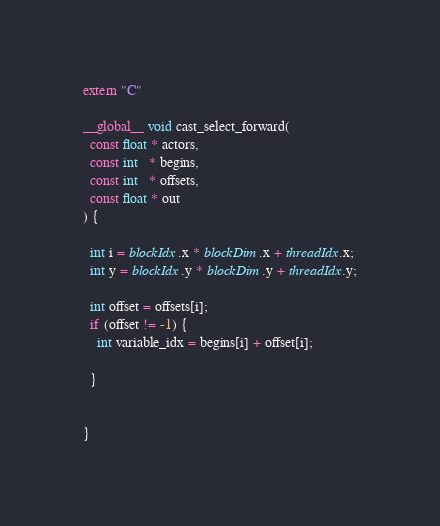<code> <loc_0><loc_0><loc_500><loc_500><_Cuda_>extern "C"

__global__ void cast_select_forward(
  const float * actors,
  const int   * begins,
  const int   * offsets,
  const float * out
) {

  int i = blockIdx.x * blockDim.x + threadIdx.x;
  int y = blockIdx.y * blockDim.y + threadIdx.y;

  int offset = offsets[i];
  if (offset != -1) {
    int variable_idx = begins[i] + offset[i];

  }
  

}
</code> 